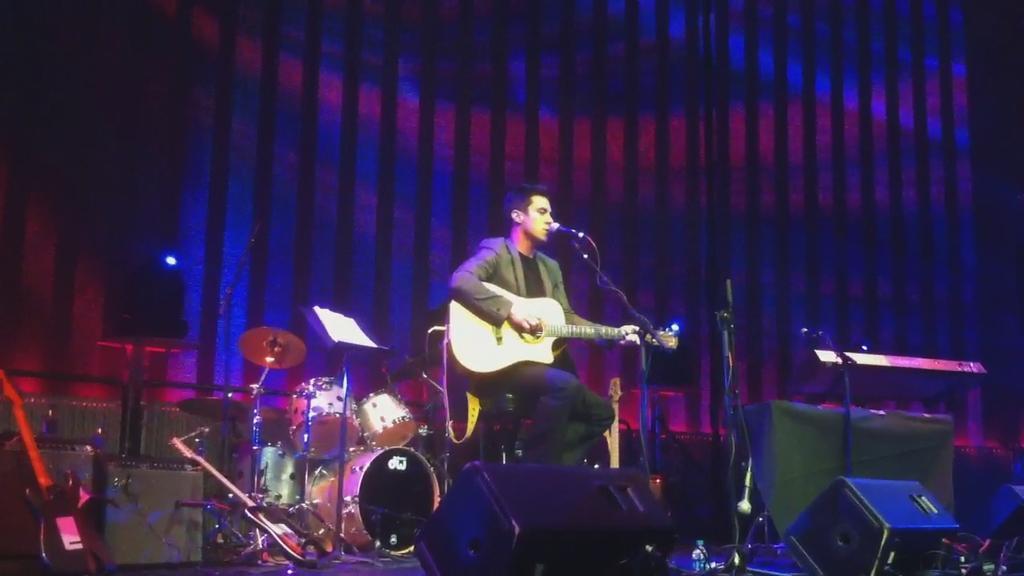Could you give a brief overview of what you see in this image? In the image we can see there is a person who is sitting and holding guitar in his hand and at the back there is a drum set. 